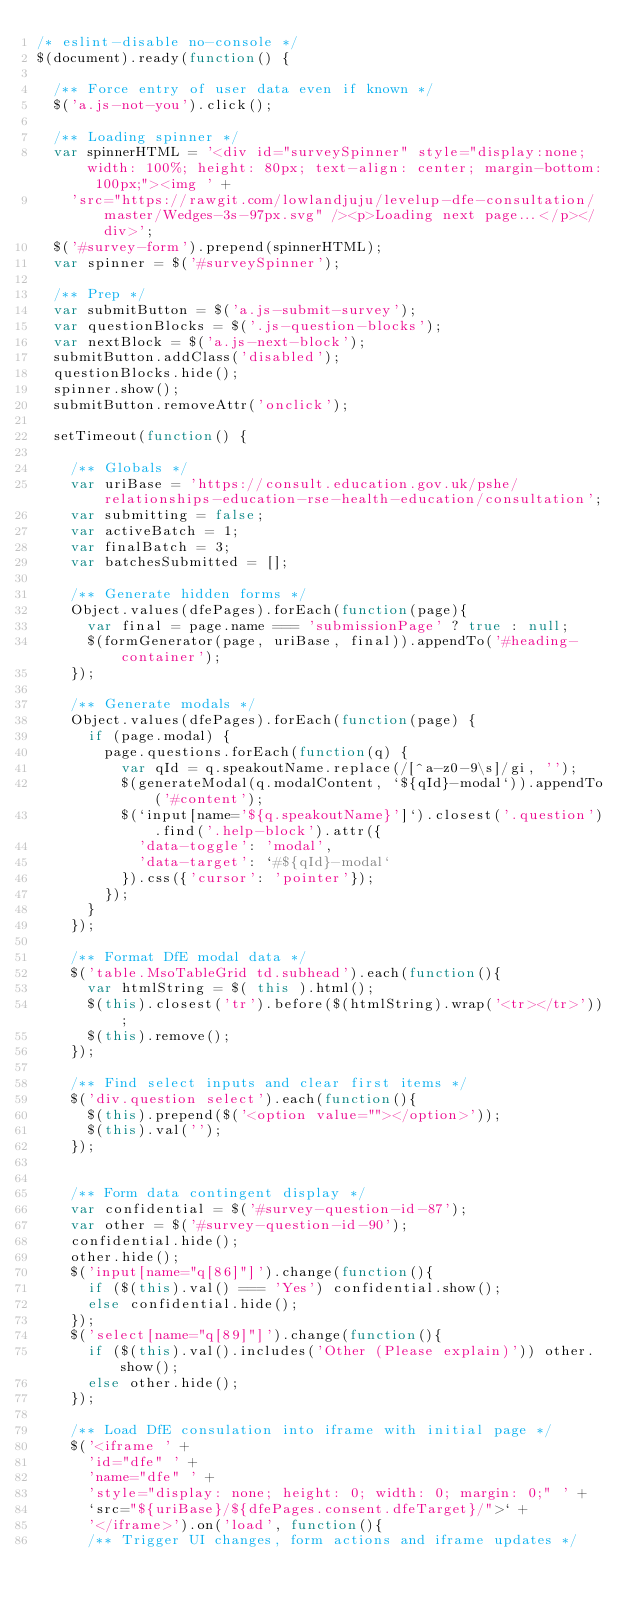Convert code to text. <code><loc_0><loc_0><loc_500><loc_500><_JavaScript_>/* eslint-disable no-console */
$(document).ready(function() {

  /** Force entry of user data even if known */
  $('a.js-not-you').click();

  /** Loading spinner */
  var spinnerHTML = '<div id="surveySpinner" style="display:none; width: 100%; height: 80px; text-align: center; margin-bottom: 100px;"><img ' +
    'src="https://rawgit.com/lowlandjuju/levelup-dfe-consultation/master/Wedges-3s-97px.svg" /><p>Loading next page...</p></div>';
  $('#survey-form').prepend(spinnerHTML);
  var spinner = $('#surveySpinner');

  /** Prep */
  var submitButton = $('a.js-submit-survey');
  var questionBlocks = $('.js-question-blocks');
  var nextBlock = $('a.js-next-block');
  submitButton.addClass('disabled');
  questionBlocks.hide();
  spinner.show();
  submitButton.removeAttr('onclick');

  setTimeout(function() {

    /** Globals */
    var uriBase = 'https://consult.education.gov.uk/pshe/relationships-education-rse-health-education/consultation';
    var submitting = false;
    var activeBatch = 1;
    var finalBatch = 3;
    var batchesSubmitted = [];

    /** Generate hidden forms */
    Object.values(dfePages).forEach(function(page){
      var final = page.name === 'submissionPage' ? true : null;
      $(formGenerator(page, uriBase, final)).appendTo('#heading-container');
    });

    /** Generate modals */
    Object.values(dfePages).forEach(function(page) {
      if (page.modal) {
        page.questions.forEach(function(q) {
          var qId = q.speakoutName.replace(/[^a-z0-9\s]/gi, '');
          $(generateModal(q.modalContent, `${qId}-modal`)).appendTo('#content');
          $(`input[name='${q.speakoutName}']`).closest('.question').find('.help-block').attr({
            'data-toggle': 'modal',
            'data-target': `#${qId}-modal`
          }).css({'cursor': 'pointer'});
        });
      }
    });

    /** Format DfE modal data */
    $('table.MsoTableGrid td.subhead').each(function(){
      var htmlString = $( this ).html();
      $(this).closest('tr').before($(htmlString).wrap('<tr></tr>'));
      $(this).remove();
    });

    /** Find select inputs and clear first items */
    $('div.question select').each(function(){
      $(this).prepend($('<option value=""></option>'));
      $(this).val('');
    });


    /** Form data contingent display */
    var confidential = $('#survey-question-id-87');
    var other = $('#survey-question-id-90');
    confidential.hide();
    other.hide();
    $('input[name="q[86]"]').change(function(){
      if ($(this).val() === 'Yes') confidential.show();
      else confidential.hide();
    });
    $('select[name="q[89]"]').change(function(){
      if ($(this).val().includes('Other (Please explain)')) other.show();
      else other.hide();
    });

    /** Load DfE consulation into iframe with initial page */
    $('<iframe ' +
      'id="dfe" ' +
      'name="dfe" ' +
      'style="display: none; height: 0; width: 0; margin: 0;" ' +
      `src="${uriBase}/${dfePages.consent.dfeTarget}/">` +
      '</iframe>').on('load', function(){
      /** Trigger UI changes, form actions and iframe updates */</code> 